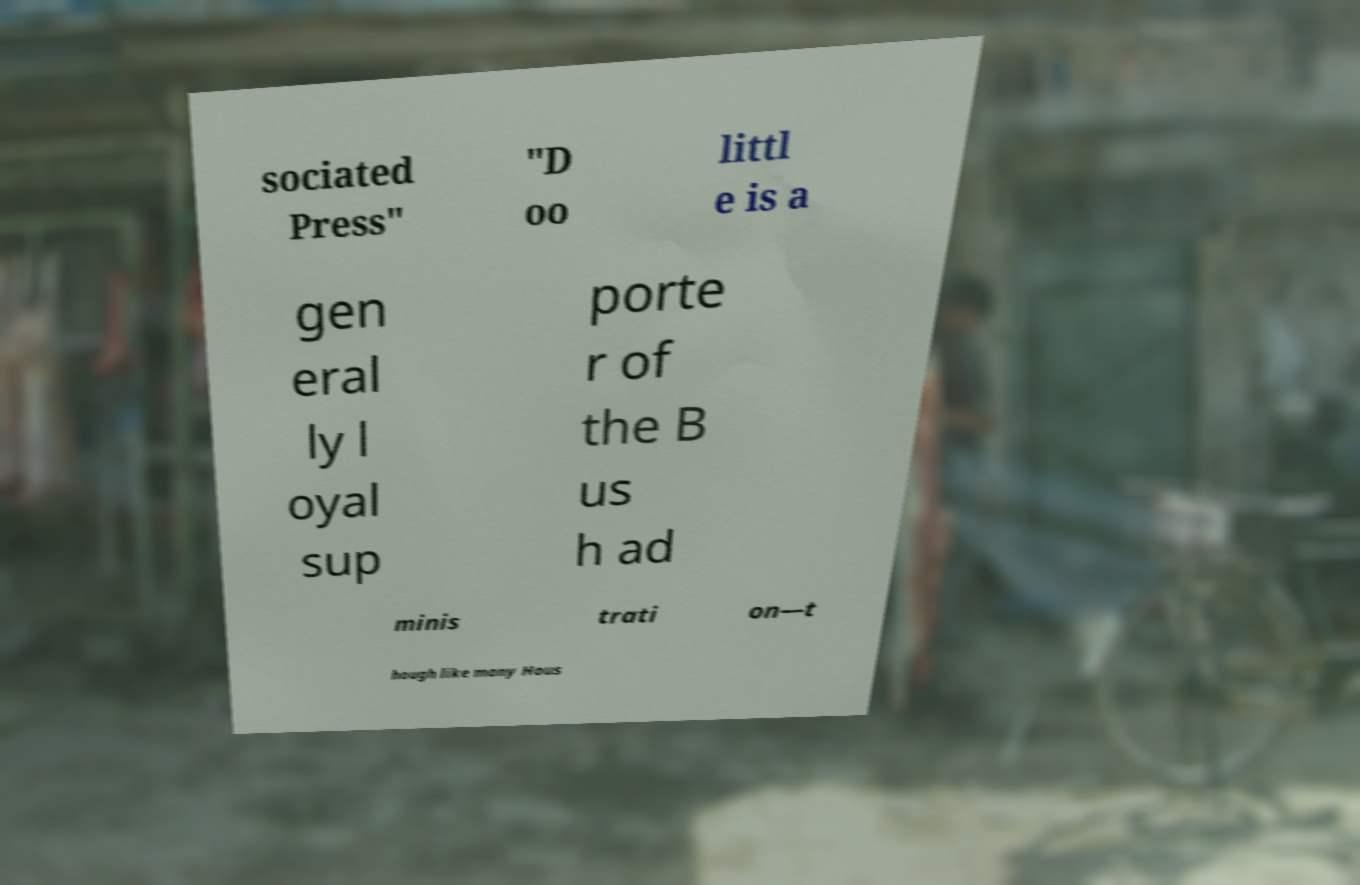Can you accurately transcribe the text from the provided image for me? sociated Press" "D oo littl e is a gen eral ly l oyal sup porte r of the B us h ad minis trati on—t hough like many Hous 